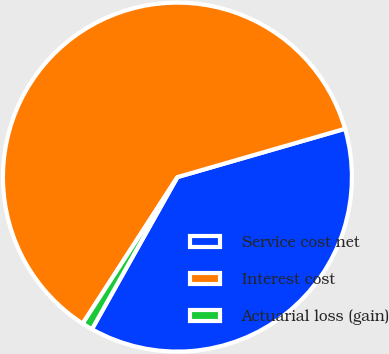Convert chart to OTSL. <chart><loc_0><loc_0><loc_500><loc_500><pie_chart><fcel>Service cost net<fcel>Interest cost<fcel>Actuarial loss (gain)<nl><fcel>37.62%<fcel>61.39%<fcel>0.99%<nl></chart> 